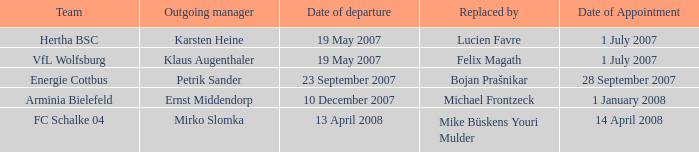When was the manager's appointment date who was succeeded by lucien favre? 1 July 2007. 